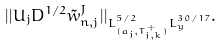<formula> <loc_0><loc_0><loc_500><loc_500>| | U _ { j } D ^ { 1 / 2 } \tilde { w } _ { n , j } ^ { J } | | _ { L ^ { 5 / 2 } _ { ( a _ { j } , T ^ { + } _ { j , k } ) } L ^ { 3 0 / 1 7 } _ { y } } .</formula> 